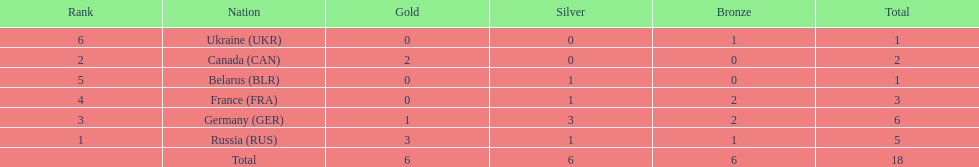Name the country that had the same number of bronze medals as russia. Ukraine. 